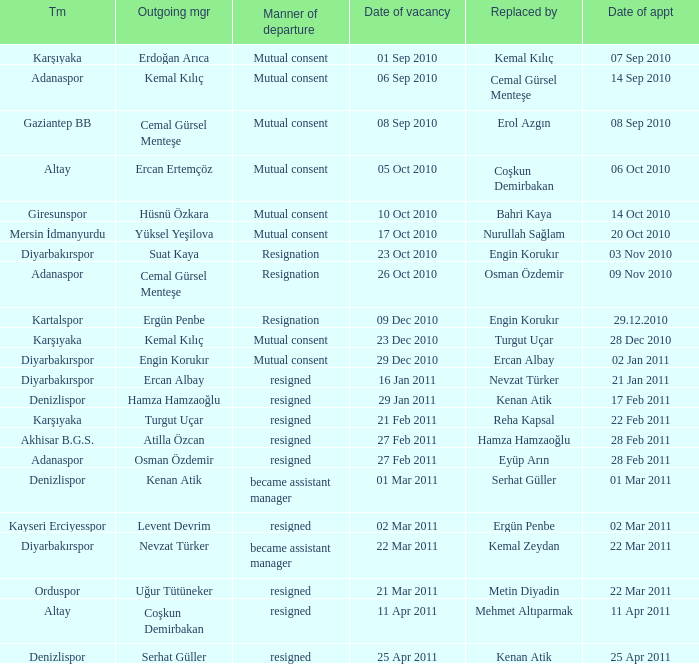Who replaced the manager of Akhisar B.G.S.? Hamza Hamzaoğlu. 